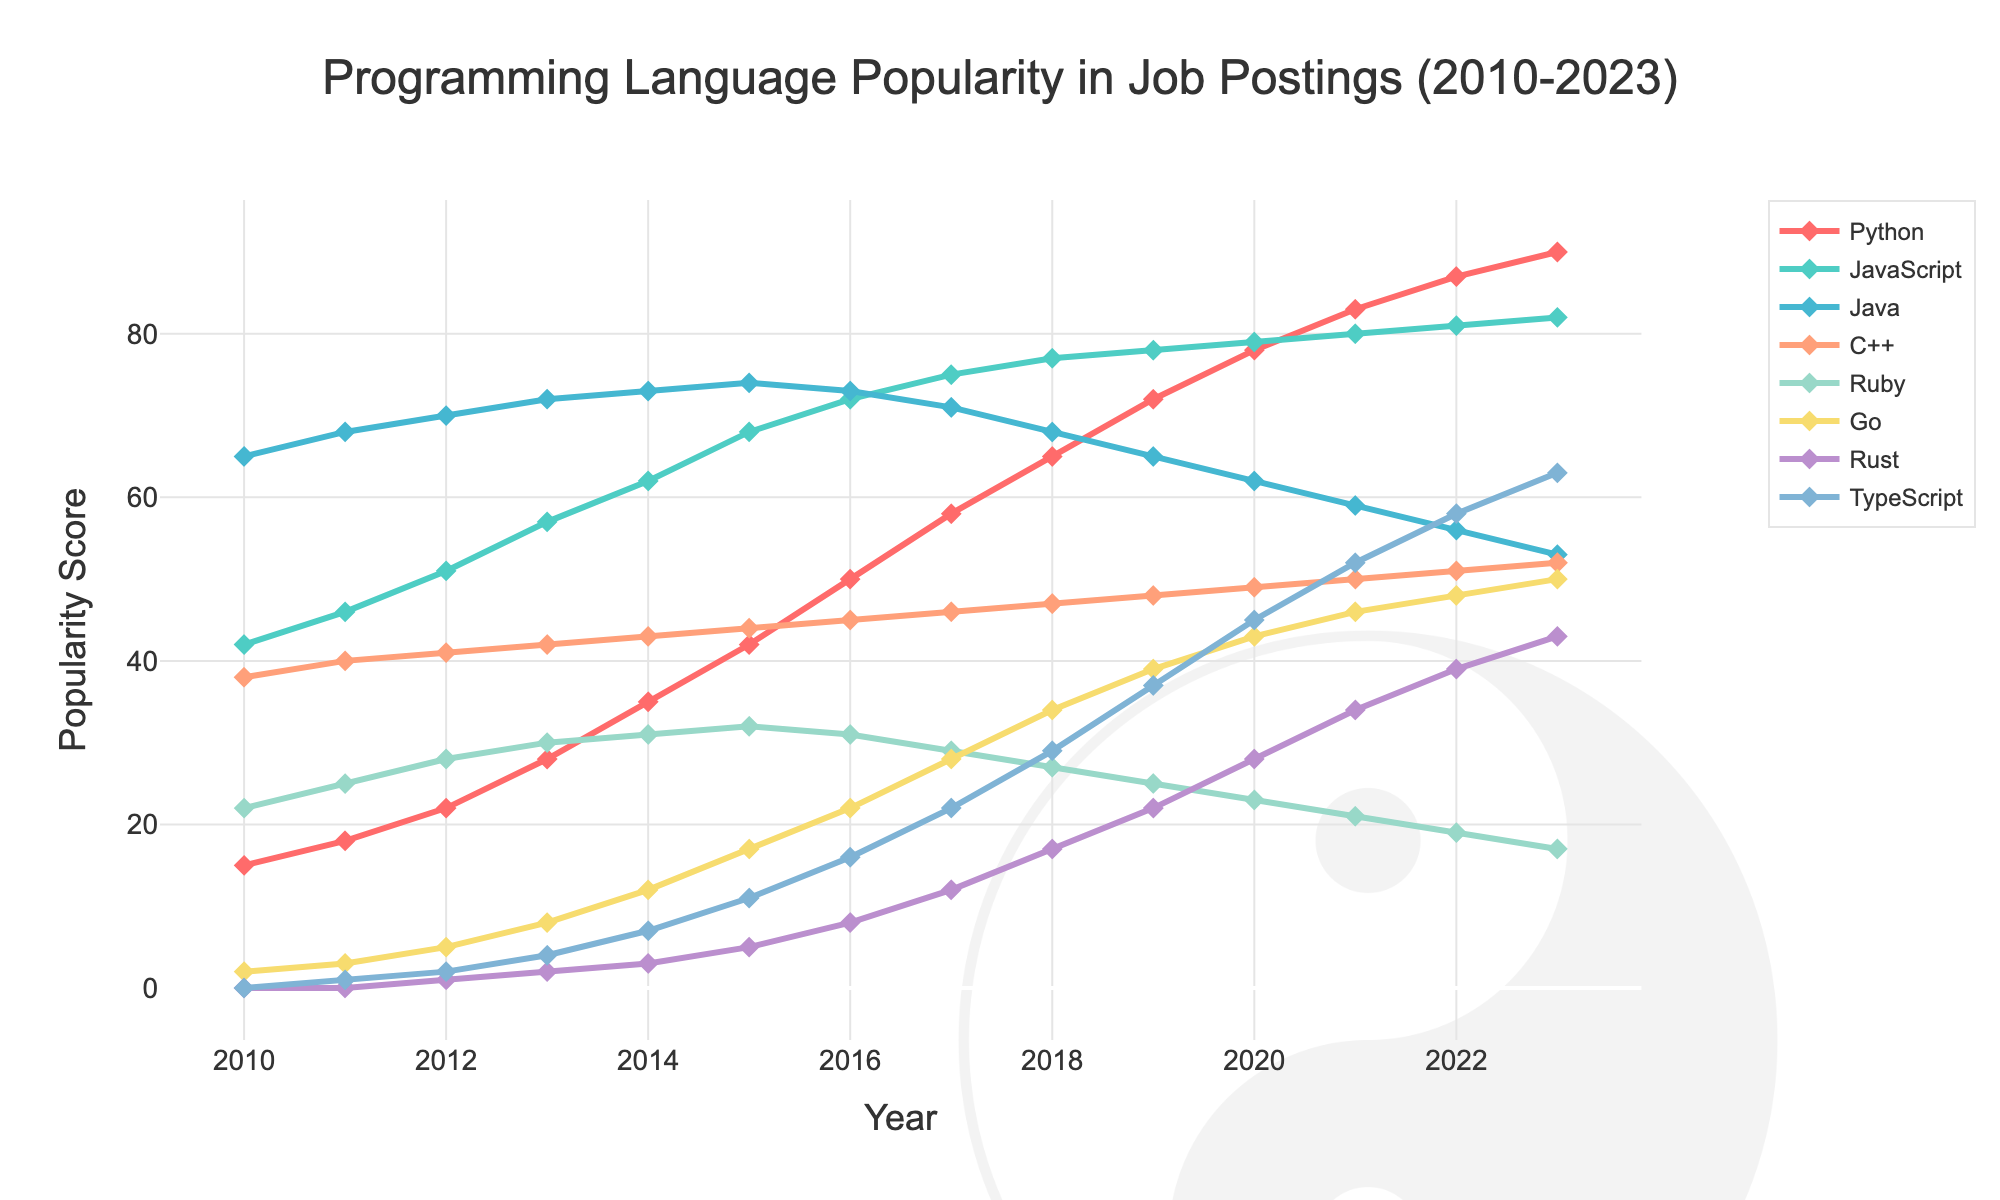What trend do you observe for the popularity of Python from 2010 to 2023? Python steadily increased in popularity from 15 in 2010 to 90 in 2023, showing a continuous upward trend throughout the years.
Answer: Steadily increasing Which programming language had the highest popularity score in 2013? In 2013, Java had the highest popularity score, reaching 72, as indicated by the topmost point in the plot for that year.
Answer: Java How did the popularity of Rust evolve from 2015 to 2023? Rust's popularity grew from 5 in 2015 to 43 in 2023, showing a gradual and consistent increase over the years.
Answer: Gradual increase In what year did TypeScript surpass C++ in popularity? TypeScript surpassed C++ in popularity in 2022 when TypeScript had a score of 58 while C++ had a score of 51.
Answer: 2022 Compare the popularity of Go and Ruby in 2020. Which was more popular and by how much? In 2020, Go had a popularity score of 43, while Ruby had a score of 23. Go was more popular by 20 points.
Answer: Go by 20 Identify the year with the biggest single-year increase in popularity for TypeScript. The biggest single-year increase for TypeScript was from 2017 to 2018, where it jumped from 22 to 29, an increase of 7 points.
Answer: 2017 to 2018 Which programming languages had a decrease in popularity from 2016 to 2023? Java and Ruby had a decrease in popularity from 2016 to 2023; Java decreased from 73 to 53 and Ruby from 31 to 17.
Answer: Java and Ruby What was the average popularity score for JavaScript between 2010 and 2023? Sum the popularity scores of JavaScript from 2010 to 2023: 42 + 46 + 51 + 57 + 62 + 68 + 72 + 75 + 77 + 78 + 79 + 80 + 81 + 82 = 950. Divide by 14 (the number of years): 950 / 14 ≈ 67.86.
Answer: ≈ 67.86 How does the increase in Python's popularity compare to the increase in Rust's popularity from 2010 to 2023? Python increased from 15 to 90, a 75-point increase. Rust increased from 0 to 43, a 43-point increase. Python's popularity increased significantly more.
Answer: Python by 75, Rust by 43 What visual pattern is associated with the popularity trend of Go on the plot? The popularity of Go shows a continuous upward curve with line markers and a noticeable rise in the latter years, especially highlighted by the diamond markers in teal green color.
Answer: Upward curve with diamond markers in teal green 